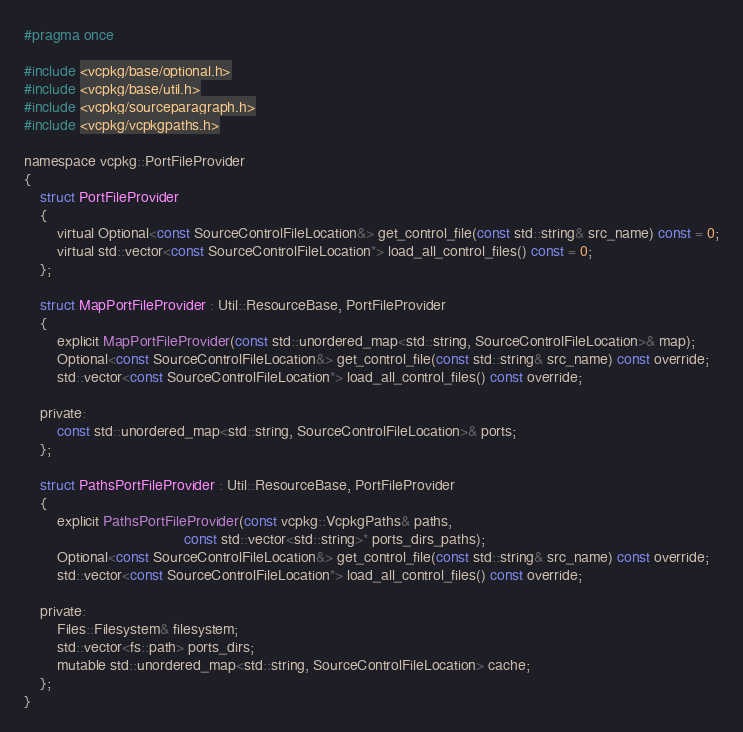Convert code to text. <code><loc_0><loc_0><loc_500><loc_500><_C_>#pragma once

#include <vcpkg/base/optional.h>
#include <vcpkg/base/util.h>
#include <vcpkg/sourceparagraph.h>
#include <vcpkg/vcpkgpaths.h>

namespace vcpkg::PortFileProvider
{
    struct PortFileProvider
    {
        virtual Optional<const SourceControlFileLocation&> get_control_file(const std::string& src_name) const = 0;
        virtual std::vector<const SourceControlFileLocation*> load_all_control_files() const = 0;
    };

    struct MapPortFileProvider : Util::ResourceBase, PortFileProvider
    {
        explicit MapPortFileProvider(const std::unordered_map<std::string, SourceControlFileLocation>& map);
        Optional<const SourceControlFileLocation&> get_control_file(const std::string& src_name) const override;
        std::vector<const SourceControlFileLocation*> load_all_control_files() const override;

    private:
        const std::unordered_map<std::string, SourceControlFileLocation>& ports;
    };

    struct PathsPortFileProvider : Util::ResourceBase, PortFileProvider
    {
        explicit PathsPortFileProvider(const vcpkg::VcpkgPaths& paths,
                                       const std::vector<std::string>* ports_dirs_paths);
        Optional<const SourceControlFileLocation&> get_control_file(const std::string& src_name) const override;
        std::vector<const SourceControlFileLocation*> load_all_control_files() const override;

    private:
        Files::Filesystem& filesystem;
        std::vector<fs::path> ports_dirs;
        mutable std::unordered_map<std::string, SourceControlFileLocation> cache;
    };
}
</code> 